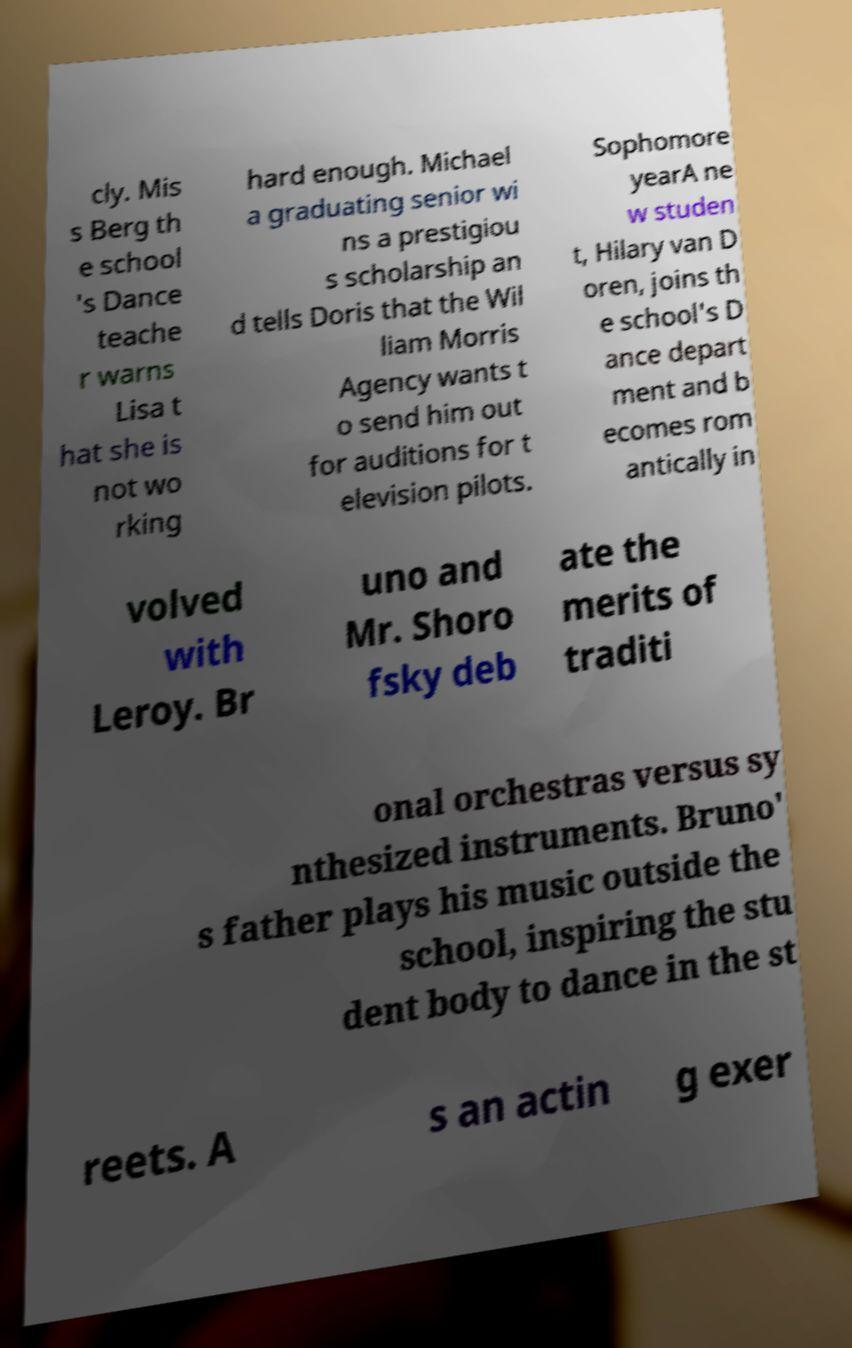There's text embedded in this image that I need extracted. Can you transcribe it verbatim? cly. Mis s Berg th e school 's Dance teache r warns Lisa t hat she is not wo rking hard enough. Michael a graduating senior wi ns a prestigiou s scholarship an d tells Doris that the Wil liam Morris Agency wants t o send him out for auditions for t elevision pilots. Sophomore yearA ne w studen t, Hilary van D oren, joins th e school's D ance depart ment and b ecomes rom antically in volved with Leroy. Br uno and Mr. Shoro fsky deb ate the merits of traditi onal orchestras versus sy nthesized instruments. Bruno' s father plays his music outside the school, inspiring the stu dent body to dance in the st reets. A s an actin g exer 